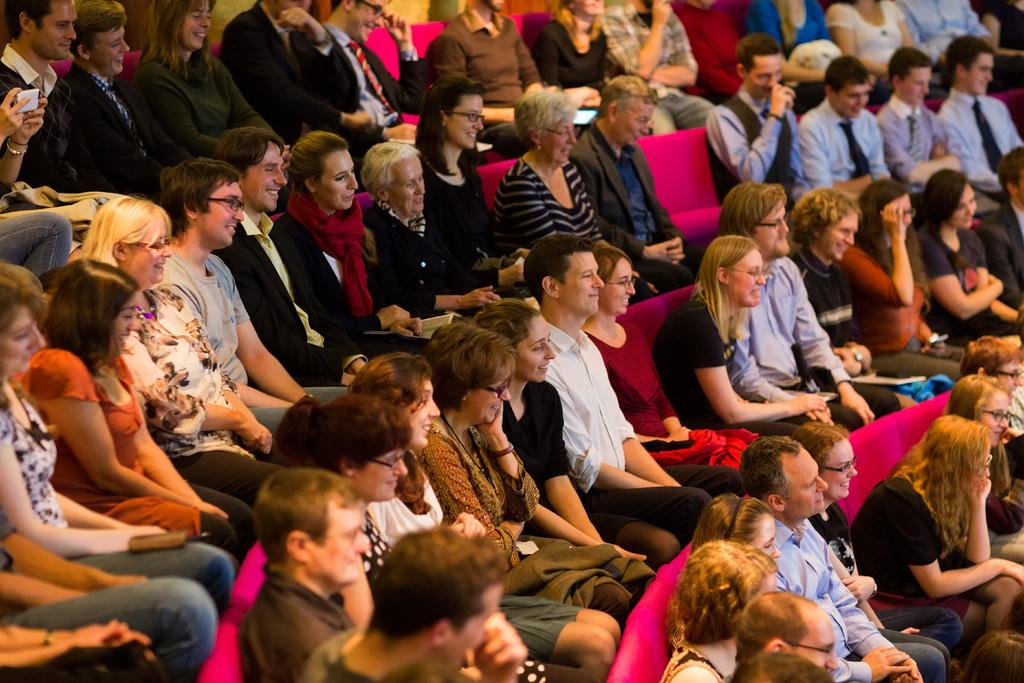How many people are in the image? There are many people in the image. What are the people sitting on? The people are sitting on pink color sofas. Can you describe any accessories that some people are wearing? Some of the people are wearing glasses (specs). What type of coat can be seen hanging on the grass in the image? There is no coat or grass present in the image; it features people sitting on pink sofas. 